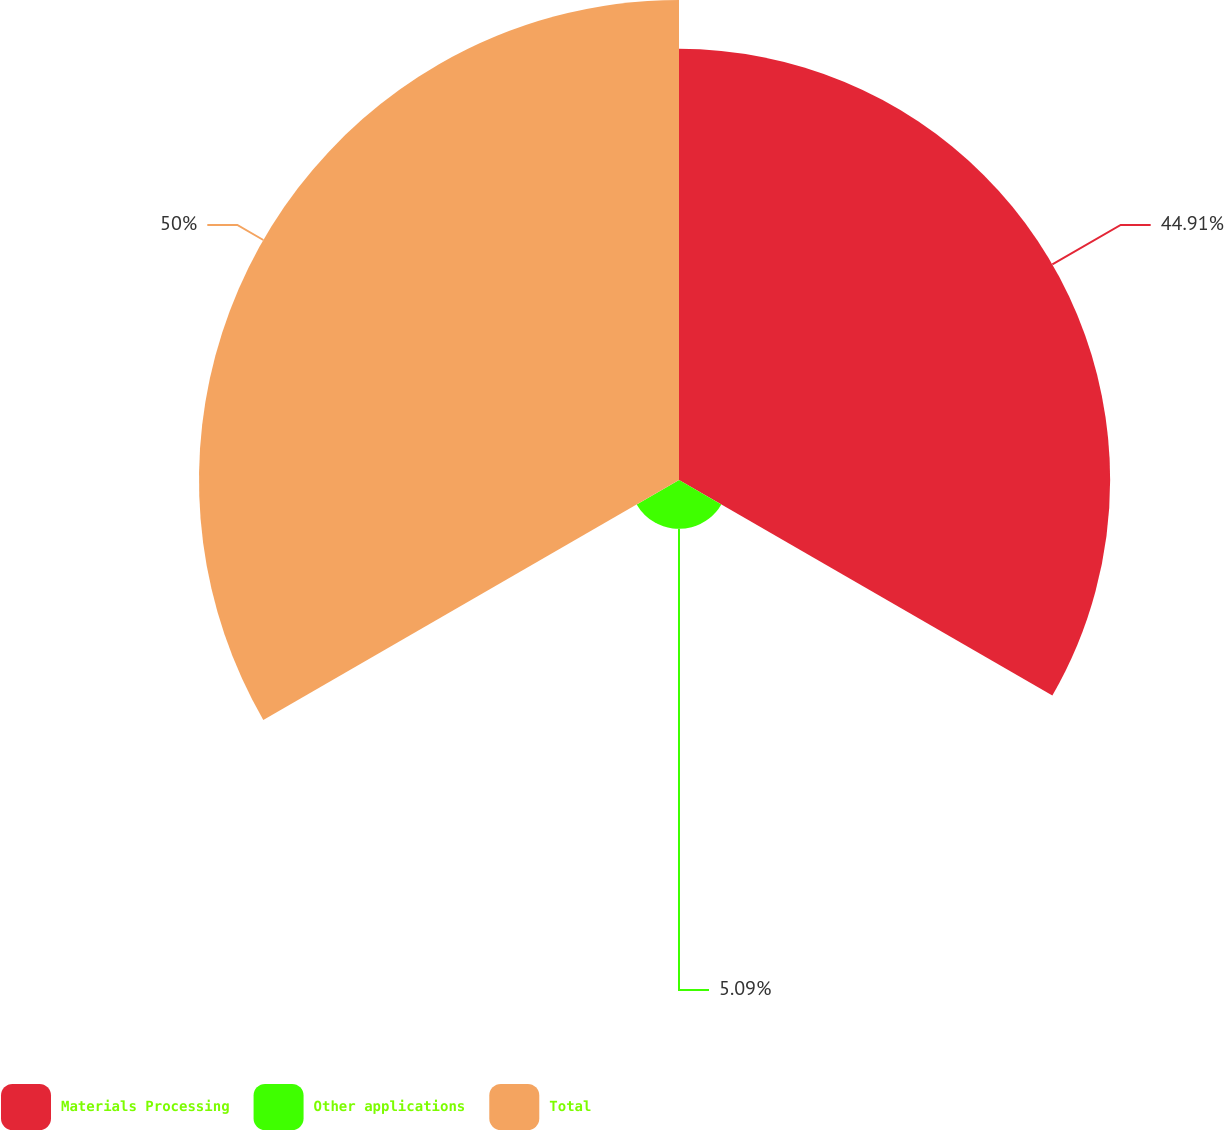<chart> <loc_0><loc_0><loc_500><loc_500><pie_chart><fcel>Materials Processing<fcel>Other applications<fcel>Total<nl><fcel>44.91%<fcel>5.09%<fcel>50.0%<nl></chart> 